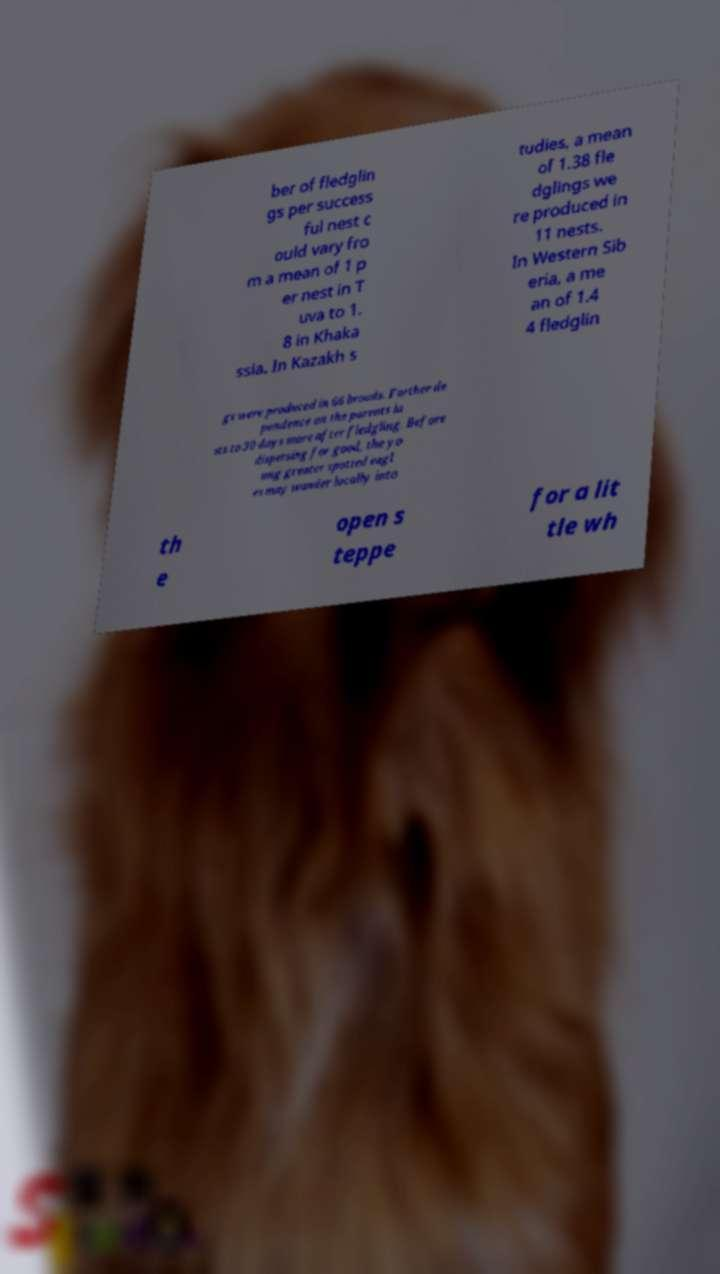Can you accurately transcribe the text from the provided image for me? ber of fledglin gs per success ful nest c ould vary fro m a mean of 1 p er nest in T uva to 1. 8 in Khaka ssia. In Kazakh s tudies, a mean of 1.38 fle dglings we re produced in 11 nests. In Western Sib eria, a me an of 1.4 4 fledglin gs were produced in 66 broods. Further de pendence on the parents la sts to 30 days more after fledgling. Before dispersing for good, the yo ung greater spotted eagl es may wander locally into th e open s teppe for a lit tle wh 